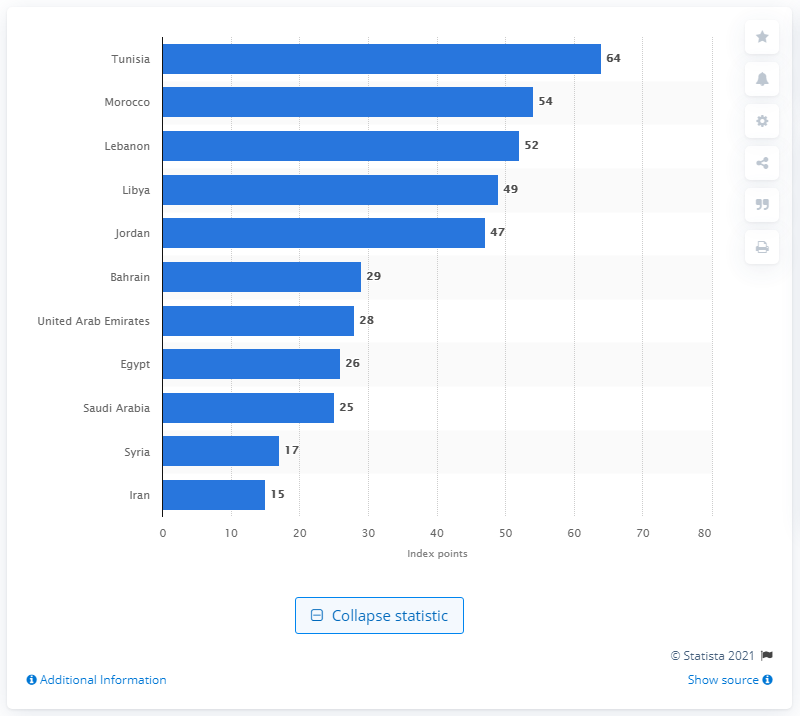List a handful of essential elements in this visual. In 2019, Tunisia had 64 index points. The country of Syria occupied the last place in terms of internet freedom in 2019, with a score of 86 on the internet freedom index. 